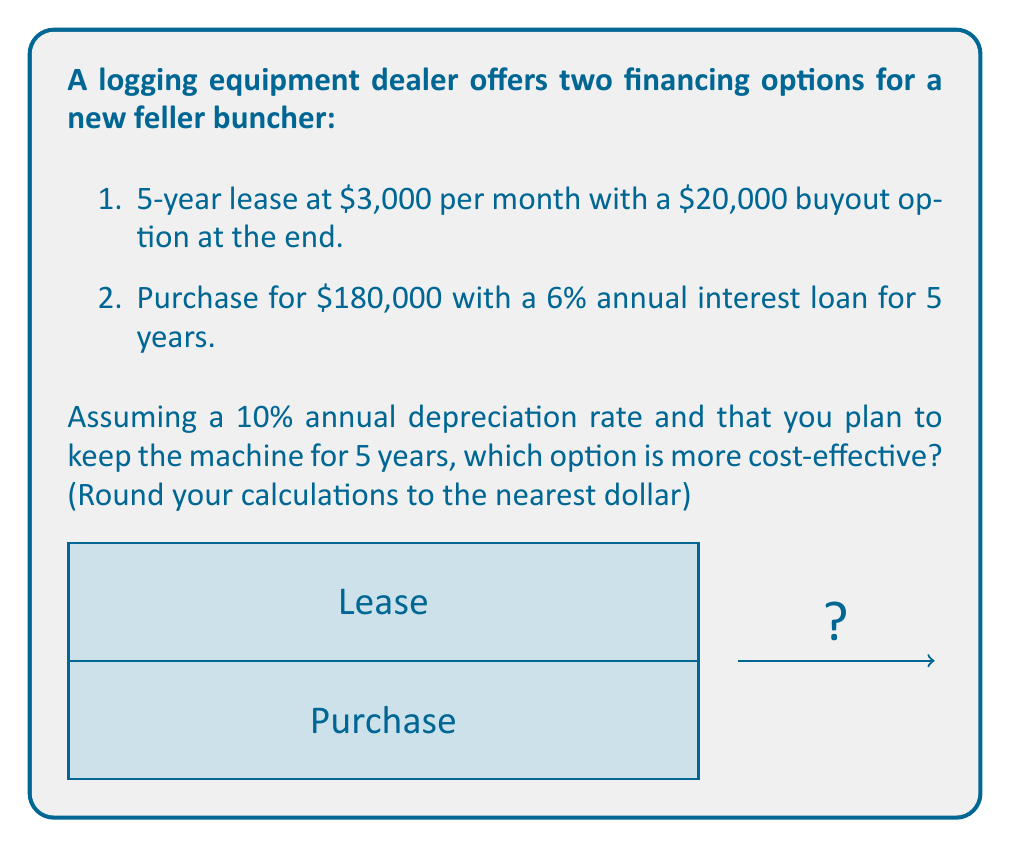Give your solution to this math problem. Let's analyze both options:

1. Lease option:
   - Monthly payments: $3,000 × 12 months × 5 years = $180,000
   - Buyout at the end: $20,000
   - Total cost: $180,000 + $20,000 = $200,000

2. Purchase option:
   - Principal: $180,000
   - Loan terms: 6% annual interest for 5 years
   - We need to calculate the monthly payment using the loan formula:
     $$P = L\frac{r(1+r)^n}{(1+r)^n-1}$$
     Where:
     $P$ = monthly payment
     $L$ = loan amount ($180,000)
     $r$ = monthly interest rate (6% / 12 = 0.5% = 0.005)
     $n$ = total number of months (5 × 12 = 60)

   $$P = 180000\frac{0.005(1+0.005)^{60}}{(1+0.005)^{60}-1} = 3,487.05$$

   - Total payments: $3,487.05 × 60 = $209,223

   However, we also need to consider the residual value of the machine after 5 years:
   - Initial value: $180,000
   - Depreciation rate: 10% per year
   - Residual value: $180,000 × (1 - 0.10)^5 = $107,973

   Actual cost = Total payments - Residual value
   $209,223 - $107,973 = $101,250

Therefore, the purchase option is more cost-effective, saving $98,750 compared to the lease option.
Answer: Purchase option ($101,250 vs. $200,000) 